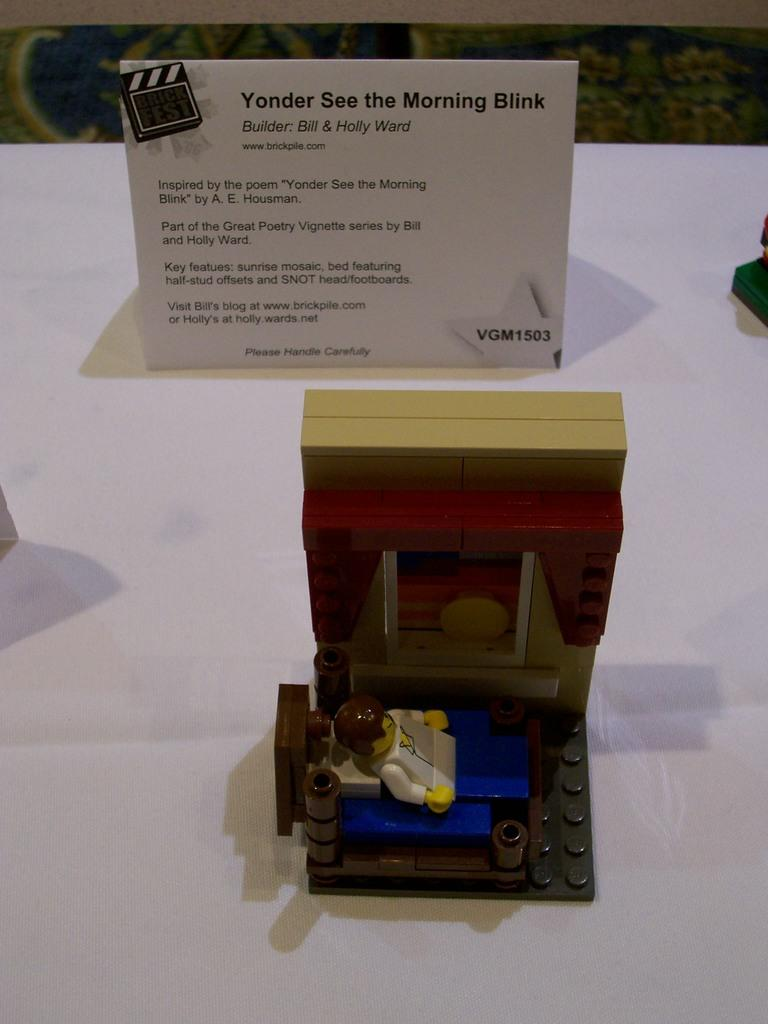<image>
Describe the image concisely. A Lego creation inspired by the poem "Yonder See the Morning Blink" sits on a white surface in front of a sign describing the creation. 